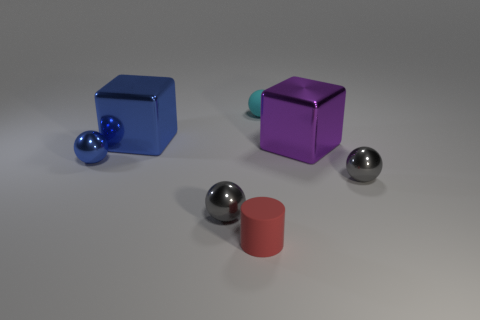How many small gray things are the same material as the large blue thing? There are two small gray spheres that appear to be made of the same reflective metal material as the large blue cube. 